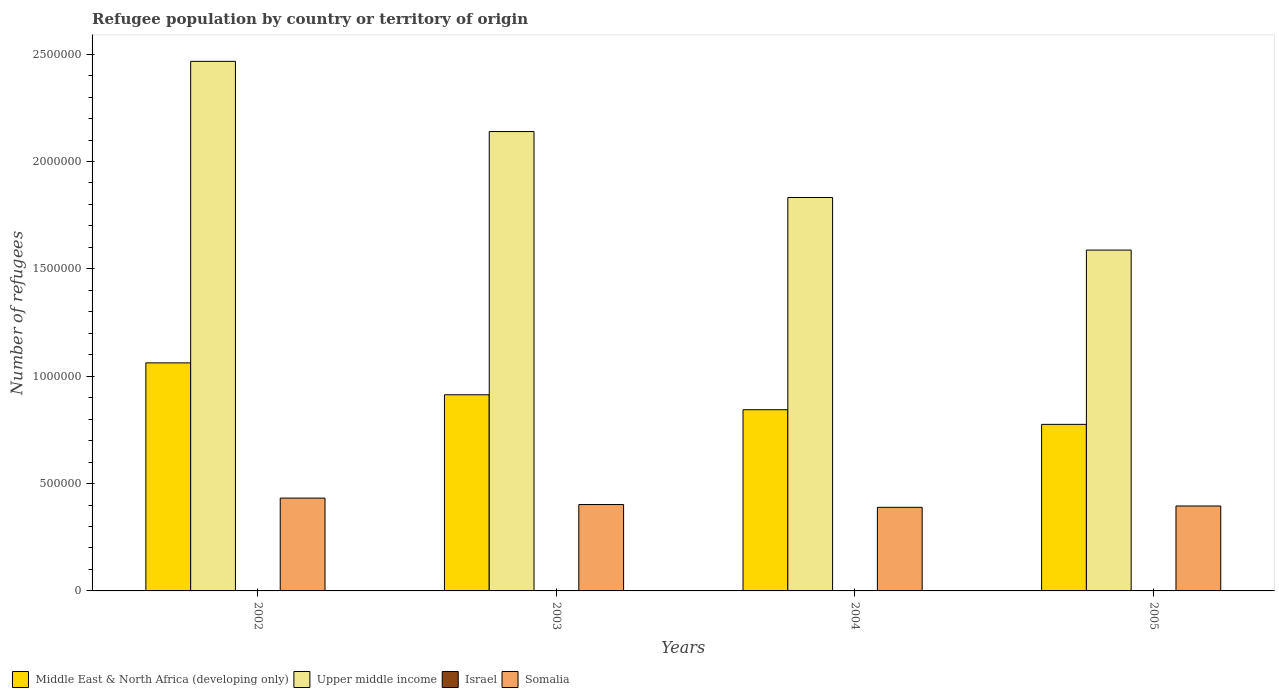Are the number of bars per tick equal to the number of legend labels?
Give a very brief answer. Yes. How many bars are there on the 3rd tick from the right?
Your response must be concise. 4. What is the number of refugees in Upper middle income in 2005?
Provide a short and direct response. 1.59e+06. Across all years, what is the maximum number of refugees in Middle East & North Africa (developing only)?
Keep it short and to the point. 1.06e+06. Across all years, what is the minimum number of refugees in Middle East & North Africa (developing only)?
Your answer should be very brief. 7.76e+05. In which year was the number of refugees in Middle East & North Africa (developing only) maximum?
Provide a short and direct response. 2002. What is the total number of refugees in Upper middle income in the graph?
Your answer should be compact. 8.03e+06. What is the difference between the number of refugees in Upper middle income in 2002 and that in 2005?
Keep it short and to the point. 8.79e+05. What is the difference between the number of refugees in Israel in 2005 and the number of refugees in Upper middle income in 2003?
Provide a succinct answer. -2.14e+06. What is the average number of refugees in Upper middle income per year?
Offer a very short reply. 2.01e+06. In the year 2004, what is the difference between the number of refugees in Somalia and number of refugees in Middle East & North Africa (developing only)?
Your answer should be compact. -4.55e+05. In how many years, is the number of refugees in Israel greater than 1500000?
Offer a very short reply. 0. What is the ratio of the number of refugees in Upper middle income in 2002 to that in 2003?
Provide a succinct answer. 1.15. What is the difference between the highest and the second highest number of refugees in Upper middle income?
Give a very brief answer. 3.27e+05. What is the difference between the highest and the lowest number of refugees in Israel?
Keep it short and to the point. 108. In how many years, is the number of refugees in Somalia greater than the average number of refugees in Somalia taken over all years?
Ensure brevity in your answer.  1. What does the 2nd bar from the left in 2004 represents?
Your response must be concise. Upper middle income. Is it the case that in every year, the sum of the number of refugees in Israel and number of refugees in Somalia is greater than the number of refugees in Middle East & North Africa (developing only)?
Your response must be concise. No. How many years are there in the graph?
Your response must be concise. 4. What is the difference between two consecutive major ticks on the Y-axis?
Your response must be concise. 5.00e+05. Are the values on the major ticks of Y-axis written in scientific E-notation?
Your answer should be compact. No. Where does the legend appear in the graph?
Ensure brevity in your answer.  Bottom left. How are the legend labels stacked?
Make the answer very short. Horizontal. What is the title of the graph?
Provide a succinct answer. Refugee population by country or territory of origin. Does "Uruguay" appear as one of the legend labels in the graph?
Make the answer very short. No. What is the label or title of the X-axis?
Ensure brevity in your answer.  Years. What is the label or title of the Y-axis?
Provide a short and direct response. Number of refugees. What is the Number of refugees of Middle East & North Africa (developing only) in 2002?
Your response must be concise. 1.06e+06. What is the Number of refugees in Upper middle income in 2002?
Keep it short and to the point. 2.47e+06. What is the Number of refugees of Israel in 2002?
Make the answer very short. 564. What is the Number of refugees in Somalia in 2002?
Your response must be concise. 4.32e+05. What is the Number of refugees in Middle East & North Africa (developing only) in 2003?
Your answer should be very brief. 9.14e+05. What is the Number of refugees of Upper middle income in 2003?
Keep it short and to the point. 2.14e+06. What is the Number of refugees of Israel in 2003?
Keep it short and to the point. 625. What is the Number of refugees of Somalia in 2003?
Ensure brevity in your answer.  4.02e+05. What is the Number of refugees in Middle East & North Africa (developing only) in 2004?
Provide a short and direct response. 8.44e+05. What is the Number of refugees of Upper middle income in 2004?
Provide a short and direct response. 1.83e+06. What is the Number of refugees of Israel in 2004?
Give a very brief answer. 672. What is the Number of refugees of Somalia in 2004?
Keep it short and to the point. 3.89e+05. What is the Number of refugees of Middle East & North Africa (developing only) in 2005?
Ensure brevity in your answer.  7.76e+05. What is the Number of refugees of Upper middle income in 2005?
Your answer should be compact. 1.59e+06. What is the Number of refugees of Israel in 2005?
Give a very brief answer. 632. What is the Number of refugees of Somalia in 2005?
Give a very brief answer. 3.96e+05. Across all years, what is the maximum Number of refugees in Middle East & North Africa (developing only)?
Your response must be concise. 1.06e+06. Across all years, what is the maximum Number of refugees in Upper middle income?
Provide a short and direct response. 2.47e+06. Across all years, what is the maximum Number of refugees of Israel?
Keep it short and to the point. 672. Across all years, what is the maximum Number of refugees of Somalia?
Your response must be concise. 4.32e+05. Across all years, what is the minimum Number of refugees in Middle East & North Africa (developing only)?
Provide a short and direct response. 7.76e+05. Across all years, what is the minimum Number of refugees in Upper middle income?
Provide a short and direct response. 1.59e+06. Across all years, what is the minimum Number of refugees of Israel?
Offer a terse response. 564. Across all years, what is the minimum Number of refugees of Somalia?
Your answer should be compact. 3.89e+05. What is the total Number of refugees of Middle East & North Africa (developing only) in the graph?
Provide a succinct answer. 3.60e+06. What is the total Number of refugees of Upper middle income in the graph?
Offer a very short reply. 8.03e+06. What is the total Number of refugees in Israel in the graph?
Ensure brevity in your answer.  2493. What is the total Number of refugees in Somalia in the graph?
Your answer should be compact. 1.62e+06. What is the difference between the Number of refugees in Middle East & North Africa (developing only) in 2002 and that in 2003?
Offer a very short reply. 1.49e+05. What is the difference between the Number of refugees of Upper middle income in 2002 and that in 2003?
Your answer should be compact. 3.27e+05. What is the difference between the Number of refugees in Israel in 2002 and that in 2003?
Provide a succinct answer. -61. What is the difference between the Number of refugees of Somalia in 2002 and that in 2003?
Provide a succinct answer. 3.00e+04. What is the difference between the Number of refugees in Middle East & North Africa (developing only) in 2002 and that in 2004?
Provide a short and direct response. 2.18e+05. What is the difference between the Number of refugees in Upper middle income in 2002 and that in 2004?
Your answer should be very brief. 6.34e+05. What is the difference between the Number of refugees of Israel in 2002 and that in 2004?
Your answer should be compact. -108. What is the difference between the Number of refugees in Somalia in 2002 and that in 2004?
Offer a very short reply. 4.30e+04. What is the difference between the Number of refugees of Middle East & North Africa (developing only) in 2002 and that in 2005?
Keep it short and to the point. 2.86e+05. What is the difference between the Number of refugees in Upper middle income in 2002 and that in 2005?
Provide a succinct answer. 8.79e+05. What is the difference between the Number of refugees of Israel in 2002 and that in 2005?
Your answer should be compact. -68. What is the difference between the Number of refugees of Somalia in 2002 and that in 2005?
Provide a succinct answer. 3.68e+04. What is the difference between the Number of refugees in Middle East & North Africa (developing only) in 2003 and that in 2004?
Your answer should be compact. 6.97e+04. What is the difference between the Number of refugees of Upper middle income in 2003 and that in 2004?
Your answer should be compact. 3.07e+05. What is the difference between the Number of refugees in Israel in 2003 and that in 2004?
Offer a terse response. -47. What is the difference between the Number of refugees in Somalia in 2003 and that in 2004?
Provide a short and direct response. 1.30e+04. What is the difference between the Number of refugees of Middle East & North Africa (developing only) in 2003 and that in 2005?
Your response must be concise. 1.38e+05. What is the difference between the Number of refugees of Upper middle income in 2003 and that in 2005?
Provide a succinct answer. 5.52e+05. What is the difference between the Number of refugees of Somalia in 2003 and that in 2005?
Offer a terse response. 6783. What is the difference between the Number of refugees in Middle East & North Africa (developing only) in 2004 and that in 2005?
Make the answer very short. 6.82e+04. What is the difference between the Number of refugees of Upper middle income in 2004 and that in 2005?
Keep it short and to the point. 2.45e+05. What is the difference between the Number of refugees of Somalia in 2004 and that in 2005?
Offer a very short reply. -6239. What is the difference between the Number of refugees in Middle East & North Africa (developing only) in 2002 and the Number of refugees in Upper middle income in 2003?
Provide a succinct answer. -1.08e+06. What is the difference between the Number of refugees of Middle East & North Africa (developing only) in 2002 and the Number of refugees of Israel in 2003?
Your response must be concise. 1.06e+06. What is the difference between the Number of refugees in Middle East & North Africa (developing only) in 2002 and the Number of refugees in Somalia in 2003?
Offer a very short reply. 6.60e+05. What is the difference between the Number of refugees of Upper middle income in 2002 and the Number of refugees of Israel in 2003?
Offer a very short reply. 2.47e+06. What is the difference between the Number of refugees of Upper middle income in 2002 and the Number of refugees of Somalia in 2003?
Provide a succinct answer. 2.06e+06. What is the difference between the Number of refugees of Israel in 2002 and the Number of refugees of Somalia in 2003?
Offer a very short reply. -4.02e+05. What is the difference between the Number of refugees of Middle East & North Africa (developing only) in 2002 and the Number of refugees of Upper middle income in 2004?
Keep it short and to the point. -7.70e+05. What is the difference between the Number of refugees of Middle East & North Africa (developing only) in 2002 and the Number of refugees of Israel in 2004?
Offer a very short reply. 1.06e+06. What is the difference between the Number of refugees of Middle East & North Africa (developing only) in 2002 and the Number of refugees of Somalia in 2004?
Make the answer very short. 6.73e+05. What is the difference between the Number of refugees of Upper middle income in 2002 and the Number of refugees of Israel in 2004?
Keep it short and to the point. 2.47e+06. What is the difference between the Number of refugees in Upper middle income in 2002 and the Number of refugees in Somalia in 2004?
Keep it short and to the point. 2.08e+06. What is the difference between the Number of refugees of Israel in 2002 and the Number of refugees of Somalia in 2004?
Make the answer very short. -3.89e+05. What is the difference between the Number of refugees in Middle East & North Africa (developing only) in 2002 and the Number of refugees in Upper middle income in 2005?
Keep it short and to the point. -5.25e+05. What is the difference between the Number of refugees in Middle East & North Africa (developing only) in 2002 and the Number of refugees in Israel in 2005?
Give a very brief answer. 1.06e+06. What is the difference between the Number of refugees in Middle East & North Africa (developing only) in 2002 and the Number of refugees in Somalia in 2005?
Provide a short and direct response. 6.67e+05. What is the difference between the Number of refugees of Upper middle income in 2002 and the Number of refugees of Israel in 2005?
Make the answer very short. 2.47e+06. What is the difference between the Number of refugees of Upper middle income in 2002 and the Number of refugees of Somalia in 2005?
Provide a short and direct response. 2.07e+06. What is the difference between the Number of refugees of Israel in 2002 and the Number of refugees of Somalia in 2005?
Offer a terse response. -3.95e+05. What is the difference between the Number of refugees of Middle East & North Africa (developing only) in 2003 and the Number of refugees of Upper middle income in 2004?
Offer a very short reply. -9.19e+05. What is the difference between the Number of refugees of Middle East & North Africa (developing only) in 2003 and the Number of refugees of Israel in 2004?
Provide a short and direct response. 9.13e+05. What is the difference between the Number of refugees of Middle East & North Africa (developing only) in 2003 and the Number of refugees of Somalia in 2004?
Provide a succinct answer. 5.24e+05. What is the difference between the Number of refugees of Upper middle income in 2003 and the Number of refugees of Israel in 2004?
Offer a very short reply. 2.14e+06. What is the difference between the Number of refugees of Upper middle income in 2003 and the Number of refugees of Somalia in 2004?
Ensure brevity in your answer.  1.75e+06. What is the difference between the Number of refugees of Israel in 2003 and the Number of refugees of Somalia in 2004?
Your answer should be compact. -3.89e+05. What is the difference between the Number of refugees of Middle East & North Africa (developing only) in 2003 and the Number of refugees of Upper middle income in 2005?
Your response must be concise. -6.74e+05. What is the difference between the Number of refugees of Middle East & North Africa (developing only) in 2003 and the Number of refugees of Israel in 2005?
Make the answer very short. 9.13e+05. What is the difference between the Number of refugees in Middle East & North Africa (developing only) in 2003 and the Number of refugees in Somalia in 2005?
Offer a terse response. 5.18e+05. What is the difference between the Number of refugees in Upper middle income in 2003 and the Number of refugees in Israel in 2005?
Your answer should be compact. 2.14e+06. What is the difference between the Number of refugees in Upper middle income in 2003 and the Number of refugees in Somalia in 2005?
Your answer should be very brief. 1.74e+06. What is the difference between the Number of refugees of Israel in 2003 and the Number of refugees of Somalia in 2005?
Offer a very short reply. -3.95e+05. What is the difference between the Number of refugees of Middle East & North Africa (developing only) in 2004 and the Number of refugees of Upper middle income in 2005?
Make the answer very short. -7.44e+05. What is the difference between the Number of refugees of Middle East & North Africa (developing only) in 2004 and the Number of refugees of Israel in 2005?
Keep it short and to the point. 8.43e+05. What is the difference between the Number of refugees of Middle East & North Africa (developing only) in 2004 and the Number of refugees of Somalia in 2005?
Your answer should be compact. 4.48e+05. What is the difference between the Number of refugees of Upper middle income in 2004 and the Number of refugees of Israel in 2005?
Give a very brief answer. 1.83e+06. What is the difference between the Number of refugees of Upper middle income in 2004 and the Number of refugees of Somalia in 2005?
Make the answer very short. 1.44e+06. What is the difference between the Number of refugees of Israel in 2004 and the Number of refugees of Somalia in 2005?
Offer a terse response. -3.95e+05. What is the average Number of refugees in Middle East & North Africa (developing only) per year?
Your answer should be compact. 8.99e+05. What is the average Number of refugees of Upper middle income per year?
Provide a succinct answer. 2.01e+06. What is the average Number of refugees of Israel per year?
Provide a short and direct response. 623.25. What is the average Number of refugees of Somalia per year?
Offer a terse response. 4.05e+05. In the year 2002, what is the difference between the Number of refugees in Middle East & North Africa (developing only) and Number of refugees in Upper middle income?
Give a very brief answer. -1.40e+06. In the year 2002, what is the difference between the Number of refugees in Middle East & North Africa (developing only) and Number of refugees in Israel?
Make the answer very short. 1.06e+06. In the year 2002, what is the difference between the Number of refugees of Middle East & North Africa (developing only) and Number of refugees of Somalia?
Keep it short and to the point. 6.30e+05. In the year 2002, what is the difference between the Number of refugees in Upper middle income and Number of refugees in Israel?
Give a very brief answer. 2.47e+06. In the year 2002, what is the difference between the Number of refugees in Upper middle income and Number of refugees in Somalia?
Offer a very short reply. 2.03e+06. In the year 2002, what is the difference between the Number of refugees of Israel and Number of refugees of Somalia?
Make the answer very short. -4.32e+05. In the year 2003, what is the difference between the Number of refugees in Middle East & North Africa (developing only) and Number of refugees in Upper middle income?
Offer a very short reply. -1.23e+06. In the year 2003, what is the difference between the Number of refugees in Middle East & North Africa (developing only) and Number of refugees in Israel?
Your response must be concise. 9.13e+05. In the year 2003, what is the difference between the Number of refugees of Middle East & North Africa (developing only) and Number of refugees of Somalia?
Your answer should be compact. 5.11e+05. In the year 2003, what is the difference between the Number of refugees of Upper middle income and Number of refugees of Israel?
Your answer should be very brief. 2.14e+06. In the year 2003, what is the difference between the Number of refugees in Upper middle income and Number of refugees in Somalia?
Your answer should be very brief. 1.74e+06. In the year 2003, what is the difference between the Number of refugees in Israel and Number of refugees in Somalia?
Give a very brief answer. -4.02e+05. In the year 2004, what is the difference between the Number of refugees in Middle East & North Africa (developing only) and Number of refugees in Upper middle income?
Ensure brevity in your answer.  -9.88e+05. In the year 2004, what is the difference between the Number of refugees of Middle East & North Africa (developing only) and Number of refugees of Israel?
Provide a short and direct response. 8.43e+05. In the year 2004, what is the difference between the Number of refugees in Middle East & North Africa (developing only) and Number of refugees in Somalia?
Offer a very short reply. 4.55e+05. In the year 2004, what is the difference between the Number of refugees of Upper middle income and Number of refugees of Israel?
Provide a succinct answer. 1.83e+06. In the year 2004, what is the difference between the Number of refugees of Upper middle income and Number of refugees of Somalia?
Your answer should be compact. 1.44e+06. In the year 2004, what is the difference between the Number of refugees in Israel and Number of refugees in Somalia?
Keep it short and to the point. -3.89e+05. In the year 2005, what is the difference between the Number of refugees in Middle East & North Africa (developing only) and Number of refugees in Upper middle income?
Make the answer very short. -8.12e+05. In the year 2005, what is the difference between the Number of refugees in Middle East & North Africa (developing only) and Number of refugees in Israel?
Ensure brevity in your answer.  7.75e+05. In the year 2005, what is the difference between the Number of refugees of Middle East & North Africa (developing only) and Number of refugees of Somalia?
Keep it short and to the point. 3.80e+05. In the year 2005, what is the difference between the Number of refugees of Upper middle income and Number of refugees of Israel?
Offer a very short reply. 1.59e+06. In the year 2005, what is the difference between the Number of refugees in Upper middle income and Number of refugees in Somalia?
Your answer should be compact. 1.19e+06. In the year 2005, what is the difference between the Number of refugees in Israel and Number of refugees in Somalia?
Keep it short and to the point. -3.95e+05. What is the ratio of the Number of refugees of Middle East & North Africa (developing only) in 2002 to that in 2003?
Provide a succinct answer. 1.16. What is the ratio of the Number of refugees of Upper middle income in 2002 to that in 2003?
Ensure brevity in your answer.  1.15. What is the ratio of the Number of refugees in Israel in 2002 to that in 2003?
Your response must be concise. 0.9. What is the ratio of the Number of refugees of Somalia in 2002 to that in 2003?
Provide a succinct answer. 1.07. What is the ratio of the Number of refugees of Middle East & North Africa (developing only) in 2002 to that in 2004?
Offer a terse response. 1.26. What is the ratio of the Number of refugees in Upper middle income in 2002 to that in 2004?
Keep it short and to the point. 1.35. What is the ratio of the Number of refugees in Israel in 2002 to that in 2004?
Make the answer very short. 0.84. What is the ratio of the Number of refugees in Somalia in 2002 to that in 2004?
Your answer should be compact. 1.11. What is the ratio of the Number of refugees in Middle East & North Africa (developing only) in 2002 to that in 2005?
Your answer should be very brief. 1.37. What is the ratio of the Number of refugees in Upper middle income in 2002 to that in 2005?
Ensure brevity in your answer.  1.55. What is the ratio of the Number of refugees of Israel in 2002 to that in 2005?
Your answer should be very brief. 0.89. What is the ratio of the Number of refugees in Somalia in 2002 to that in 2005?
Offer a terse response. 1.09. What is the ratio of the Number of refugees in Middle East & North Africa (developing only) in 2003 to that in 2004?
Provide a short and direct response. 1.08. What is the ratio of the Number of refugees in Upper middle income in 2003 to that in 2004?
Offer a terse response. 1.17. What is the ratio of the Number of refugees in Israel in 2003 to that in 2004?
Offer a very short reply. 0.93. What is the ratio of the Number of refugees of Somalia in 2003 to that in 2004?
Ensure brevity in your answer.  1.03. What is the ratio of the Number of refugees in Middle East & North Africa (developing only) in 2003 to that in 2005?
Provide a short and direct response. 1.18. What is the ratio of the Number of refugees of Upper middle income in 2003 to that in 2005?
Make the answer very short. 1.35. What is the ratio of the Number of refugees in Israel in 2003 to that in 2005?
Make the answer very short. 0.99. What is the ratio of the Number of refugees in Somalia in 2003 to that in 2005?
Your response must be concise. 1.02. What is the ratio of the Number of refugees in Middle East & North Africa (developing only) in 2004 to that in 2005?
Keep it short and to the point. 1.09. What is the ratio of the Number of refugees of Upper middle income in 2004 to that in 2005?
Give a very brief answer. 1.15. What is the ratio of the Number of refugees in Israel in 2004 to that in 2005?
Ensure brevity in your answer.  1.06. What is the ratio of the Number of refugees of Somalia in 2004 to that in 2005?
Provide a succinct answer. 0.98. What is the difference between the highest and the second highest Number of refugees in Middle East & North Africa (developing only)?
Give a very brief answer. 1.49e+05. What is the difference between the highest and the second highest Number of refugees of Upper middle income?
Give a very brief answer. 3.27e+05. What is the difference between the highest and the second highest Number of refugees in Somalia?
Provide a succinct answer. 3.00e+04. What is the difference between the highest and the lowest Number of refugees of Middle East & North Africa (developing only)?
Ensure brevity in your answer.  2.86e+05. What is the difference between the highest and the lowest Number of refugees in Upper middle income?
Your answer should be compact. 8.79e+05. What is the difference between the highest and the lowest Number of refugees in Israel?
Provide a short and direct response. 108. What is the difference between the highest and the lowest Number of refugees of Somalia?
Your answer should be very brief. 4.30e+04. 